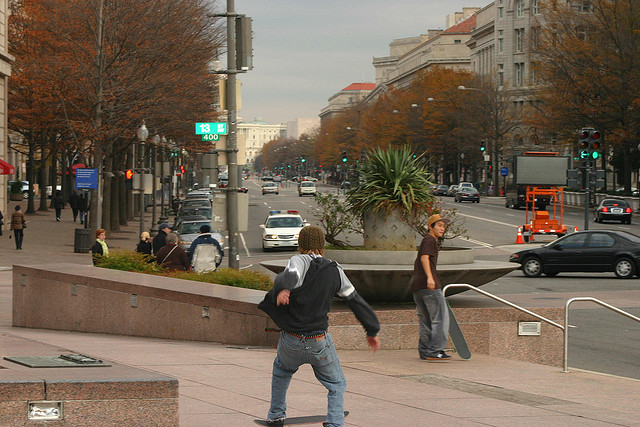<image>Where is the no-left-turn sign? I don't know where the no-left-turn sign is. It's not clearly seen in the image. Where is the no-left-turn sign? I am not sure where the no-left-turn sign is. It seems to be missing. 